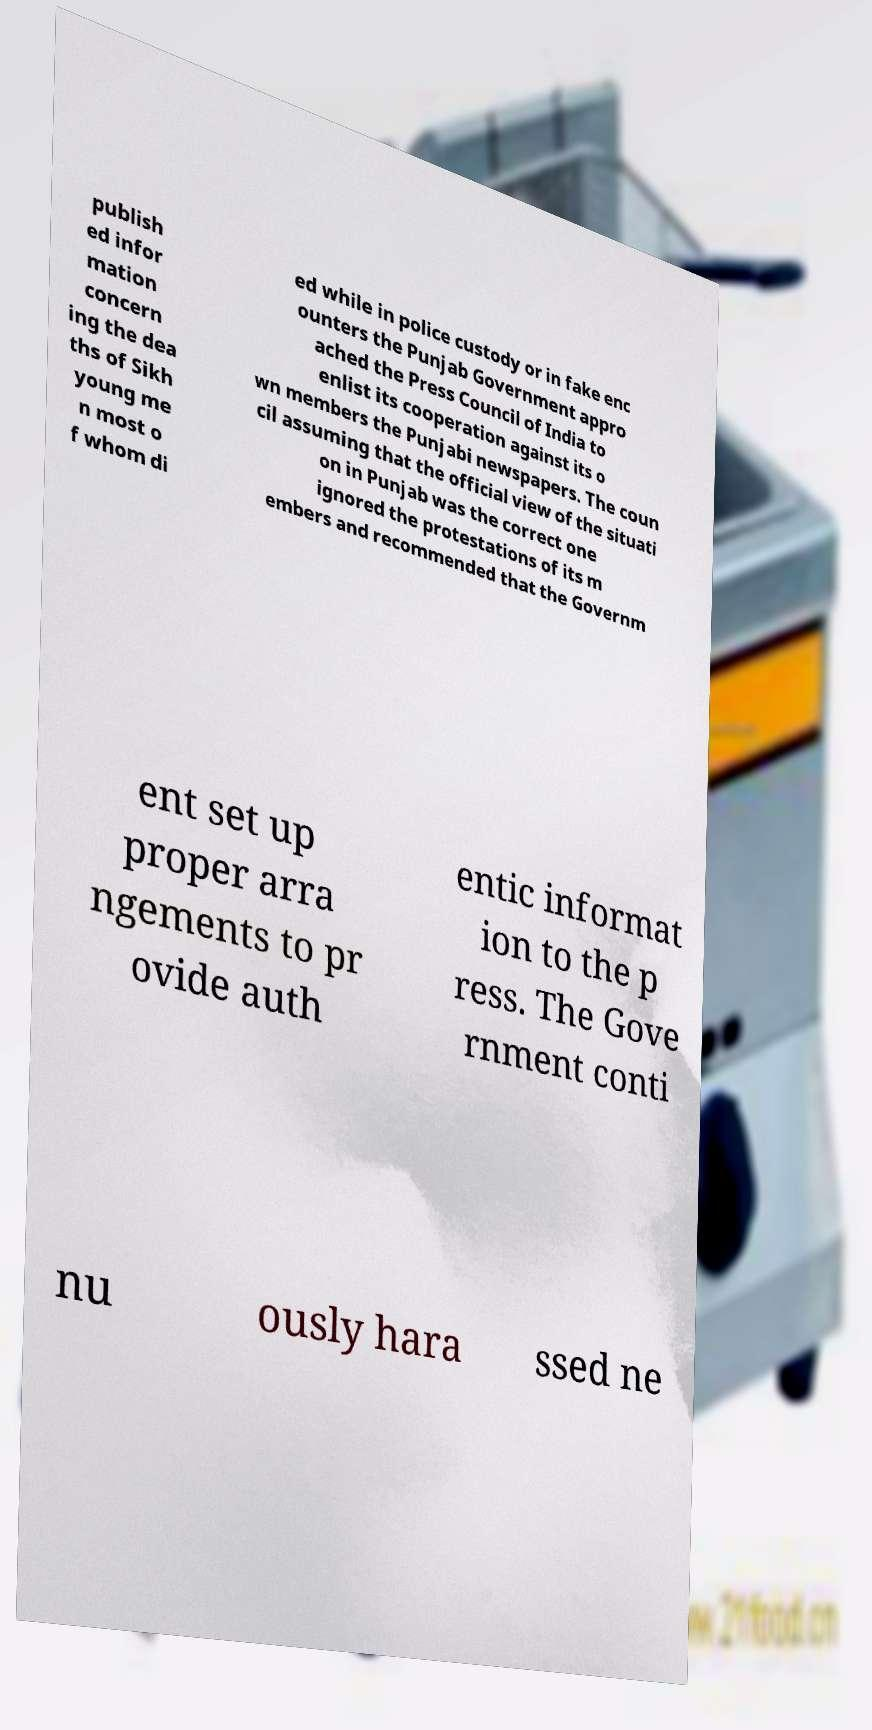What messages or text are displayed in this image? I need them in a readable, typed format. publish ed infor mation concern ing the dea ths of Sikh young me n most o f whom di ed while in police custody or in fake enc ounters the Punjab Government appro ached the Press Council of India to enlist its cooperation against its o wn members the Punjabi newspapers. The coun cil assuming that the official view of the situati on in Punjab was the correct one ignored the protestations of its m embers and recommended that the Governm ent set up proper arra ngements to pr ovide auth entic informat ion to the p ress. The Gove rnment conti nu ously hara ssed ne 